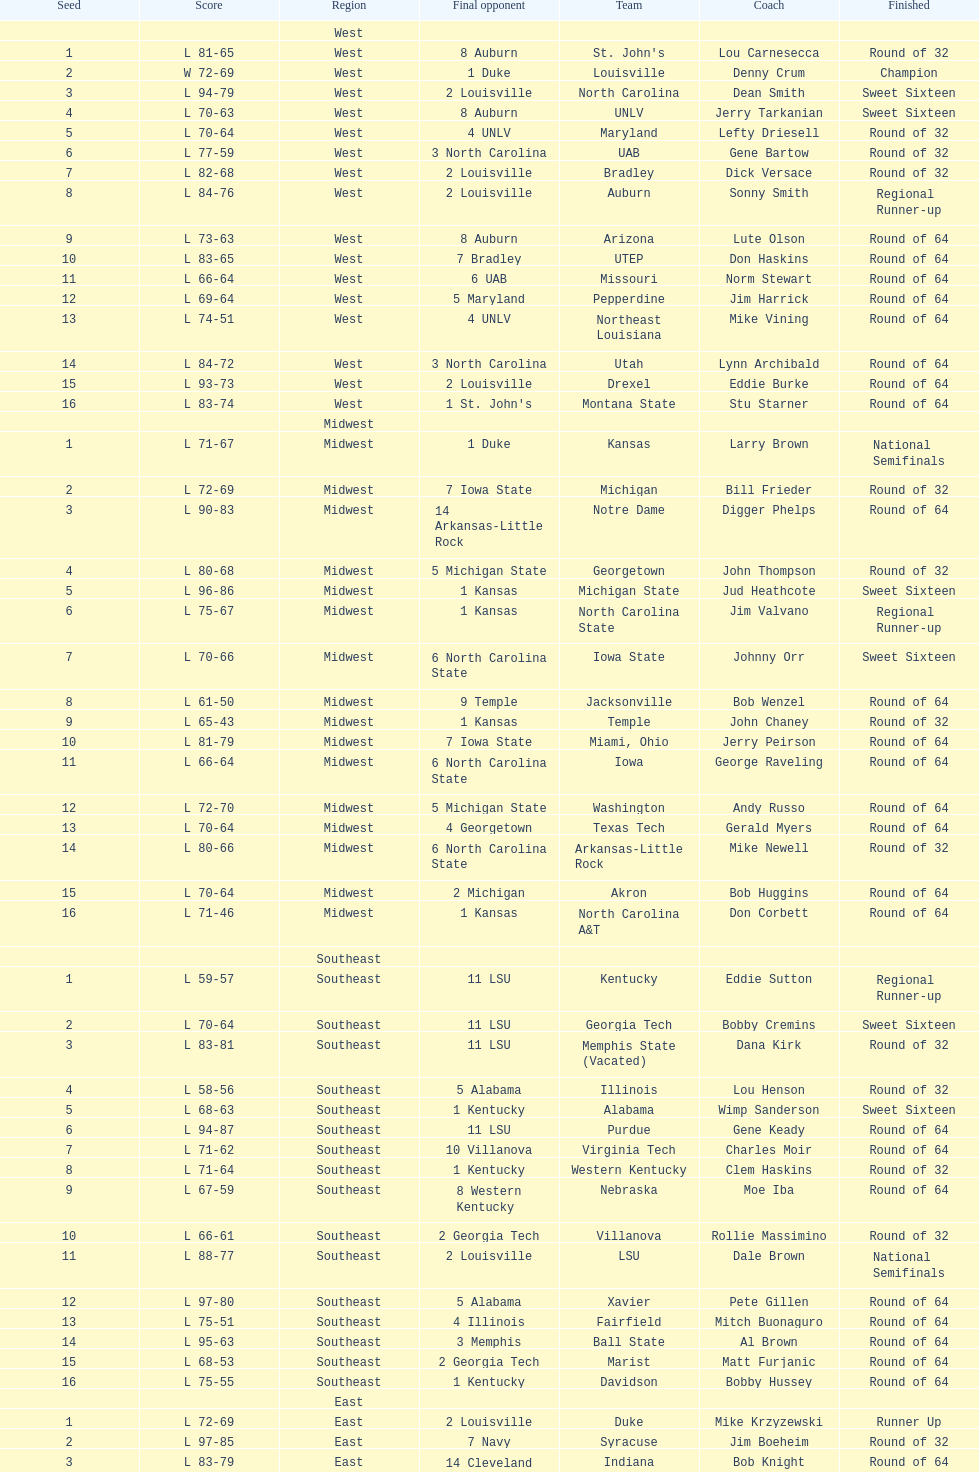Could you help me parse every detail presented in this table? {'header': ['Seed', 'Score', 'Region', 'Final opponent', 'Team', 'Coach', 'Finished'], 'rows': [['', '', 'West', '', '', '', ''], ['1', 'L 81-65', 'West', '8 Auburn', "St. John's", 'Lou Carnesecca', 'Round of 32'], ['2', 'W 72-69', 'West', '1 Duke', 'Louisville', 'Denny Crum', 'Champion'], ['3', 'L 94-79', 'West', '2 Louisville', 'North Carolina', 'Dean Smith', 'Sweet Sixteen'], ['4', 'L 70-63', 'West', '8 Auburn', 'UNLV', 'Jerry Tarkanian', 'Sweet Sixteen'], ['5', 'L 70-64', 'West', '4 UNLV', 'Maryland', 'Lefty Driesell', 'Round of 32'], ['6', 'L 77-59', 'West', '3 North Carolina', 'UAB', 'Gene Bartow', 'Round of 32'], ['7', 'L 82-68', 'West', '2 Louisville', 'Bradley', 'Dick Versace', 'Round of 32'], ['8', 'L 84-76', 'West', '2 Louisville', 'Auburn', 'Sonny Smith', 'Regional Runner-up'], ['9', 'L 73-63', 'West', '8 Auburn', 'Arizona', 'Lute Olson', 'Round of 64'], ['10', 'L 83-65', 'West', '7 Bradley', 'UTEP', 'Don Haskins', 'Round of 64'], ['11', 'L 66-64', 'West', '6 UAB', 'Missouri', 'Norm Stewart', 'Round of 64'], ['12', 'L 69-64', 'West', '5 Maryland', 'Pepperdine', 'Jim Harrick', 'Round of 64'], ['13', 'L 74-51', 'West', '4 UNLV', 'Northeast Louisiana', 'Mike Vining', 'Round of 64'], ['14', 'L 84-72', 'West', '3 North Carolina', 'Utah', 'Lynn Archibald', 'Round of 64'], ['15', 'L 93-73', 'West', '2 Louisville', 'Drexel', 'Eddie Burke', 'Round of 64'], ['16', 'L 83-74', 'West', "1 St. John's", 'Montana State', 'Stu Starner', 'Round of 64'], ['', '', 'Midwest', '', '', '', ''], ['1', 'L 71-67', 'Midwest', '1 Duke', 'Kansas', 'Larry Brown', 'National Semifinals'], ['2', 'L 72-69', 'Midwest', '7 Iowa State', 'Michigan', 'Bill Frieder', 'Round of 32'], ['3', 'L 90-83', 'Midwest', '14 Arkansas-Little Rock', 'Notre Dame', 'Digger Phelps', 'Round of 64'], ['4', 'L 80-68', 'Midwest', '5 Michigan State', 'Georgetown', 'John Thompson', 'Round of 32'], ['5', 'L 96-86', 'Midwest', '1 Kansas', 'Michigan State', 'Jud Heathcote', 'Sweet Sixteen'], ['6', 'L 75-67', 'Midwest', '1 Kansas', 'North Carolina State', 'Jim Valvano', 'Regional Runner-up'], ['7', 'L 70-66', 'Midwest', '6 North Carolina State', 'Iowa State', 'Johnny Orr', 'Sweet Sixteen'], ['8', 'L 61-50', 'Midwest', '9 Temple', 'Jacksonville', 'Bob Wenzel', 'Round of 64'], ['9', 'L 65-43', 'Midwest', '1 Kansas', 'Temple', 'John Chaney', 'Round of 32'], ['10', 'L 81-79', 'Midwest', '7 Iowa State', 'Miami, Ohio', 'Jerry Peirson', 'Round of 64'], ['11', 'L 66-64', 'Midwest', '6 North Carolina State', 'Iowa', 'George Raveling', 'Round of 64'], ['12', 'L 72-70', 'Midwest', '5 Michigan State', 'Washington', 'Andy Russo', 'Round of 64'], ['13', 'L 70-64', 'Midwest', '4 Georgetown', 'Texas Tech', 'Gerald Myers', 'Round of 64'], ['14', 'L 80-66', 'Midwest', '6 North Carolina State', 'Arkansas-Little Rock', 'Mike Newell', 'Round of 32'], ['15', 'L 70-64', 'Midwest', '2 Michigan', 'Akron', 'Bob Huggins', 'Round of 64'], ['16', 'L 71-46', 'Midwest', '1 Kansas', 'North Carolina A&T', 'Don Corbett', 'Round of 64'], ['', '', 'Southeast', '', '', '', ''], ['1', 'L 59-57', 'Southeast', '11 LSU', 'Kentucky', 'Eddie Sutton', 'Regional Runner-up'], ['2', 'L 70-64', 'Southeast', '11 LSU', 'Georgia Tech', 'Bobby Cremins', 'Sweet Sixteen'], ['3', 'L 83-81', 'Southeast', '11 LSU', 'Memphis State (Vacated)', 'Dana Kirk', 'Round of 32'], ['4', 'L 58-56', 'Southeast', '5 Alabama', 'Illinois', 'Lou Henson', 'Round of 32'], ['5', 'L 68-63', 'Southeast', '1 Kentucky', 'Alabama', 'Wimp Sanderson', 'Sweet Sixteen'], ['6', 'L 94-87', 'Southeast', '11 LSU', 'Purdue', 'Gene Keady', 'Round of 64'], ['7', 'L 71-62', 'Southeast', '10 Villanova', 'Virginia Tech', 'Charles Moir', 'Round of 64'], ['8', 'L 71-64', 'Southeast', '1 Kentucky', 'Western Kentucky', 'Clem Haskins', 'Round of 32'], ['9', 'L 67-59', 'Southeast', '8 Western Kentucky', 'Nebraska', 'Moe Iba', 'Round of 64'], ['10', 'L 66-61', 'Southeast', '2 Georgia Tech', 'Villanova', 'Rollie Massimino', 'Round of 32'], ['11', 'L 88-77', 'Southeast', '2 Louisville', 'LSU', 'Dale Brown', 'National Semifinals'], ['12', 'L 97-80', 'Southeast', '5 Alabama', 'Xavier', 'Pete Gillen', 'Round of 64'], ['13', 'L 75-51', 'Southeast', '4 Illinois', 'Fairfield', 'Mitch Buonaguro', 'Round of 64'], ['14', 'L 95-63', 'Southeast', '3 Memphis', 'Ball State', 'Al Brown', 'Round of 64'], ['15', 'L 68-53', 'Southeast', '2 Georgia Tech', 'Marist', 'Matt Furjanic', 'Round of 64'], ['16', 'L 75-55', 'Southeast', '1 Kentucky', 'Davidson', 'Bobby Hussey', 'Round of 64'], ['', '', 'East', '', '', '', ''], ['1', 'L 72-69', 'East', '2 Louisville', 'Duke', 'Mike Krzyzewski', 'Runner Up'], ['2', 'L 97-85', 'East', '7 Navy', 'Syracuse', 'Jim Boeheim', 'Round of 32'], ['3', 'L 83-79', 'East', '14 Cleveland State', 'Indiana', 'Bob Knight', 'Round of 64'], ['4', 'L 74-69', 'East', '12 DePaul', 'Oklahoma', 'Billy Tubbs', 'Round of 32'], ['5', 'L 72-68', 'East', '12 DePaul', 'Virginia', 'Terry Holland', 'Round of 64'], ['6', 'L 75-69', 'East', '14 Cleveland State', "Saint Joseph's", 'Jim Boyle', 'Round of 32'], ['7', 'L 71-50', 'East', '1 Duke', 'Navy', 'Paul Evans', 'Regional Runner-up'], ['8', 'L 89-61', 'East', '1 Duke', 'Old Dominion', 'Tom Young', 'Round of 32'], ['9', 'L 72-64', 'East', '8 Old Dominion', 'West Virginia', 'Gale Catlett', 'Round of 64'], ['10', 'L 87-68', 'East', '7 Navy', 'Tulsa', 'J. D. Barnett', 'Round of 64'], ['11', 'L 60-59', 'East', "6 Saint Joseph's", 'Richmond', 'Dick Tarrant', 'Round of 64'], ['12', 'L 74-67', 'East', '1 Duke', 'DePaul', 'Joey Meyer', 'Sweet Sixteen'], ['13', 'L 80-74', 'East', '4 Oklahoma', 'Northeastern', 'Jim Calhoun', 'Round of 64'], ['14', 'L 71-70', 'East', '7 Navy', 'Cleveland State', 'Kevin Mackey', 'Sweet Sixteen'], ['15', 'L 101-52', 'East', '2 Syracuse', 'Brown', 'Mike Cingiser', 'Round of 64'], ['16', 'L 85-78', 'East', '1 Duke', 'Mississippi Valley State', 'Lafayette Stribling', 'Round of 64']]} Who was the only champion? Louisville. 